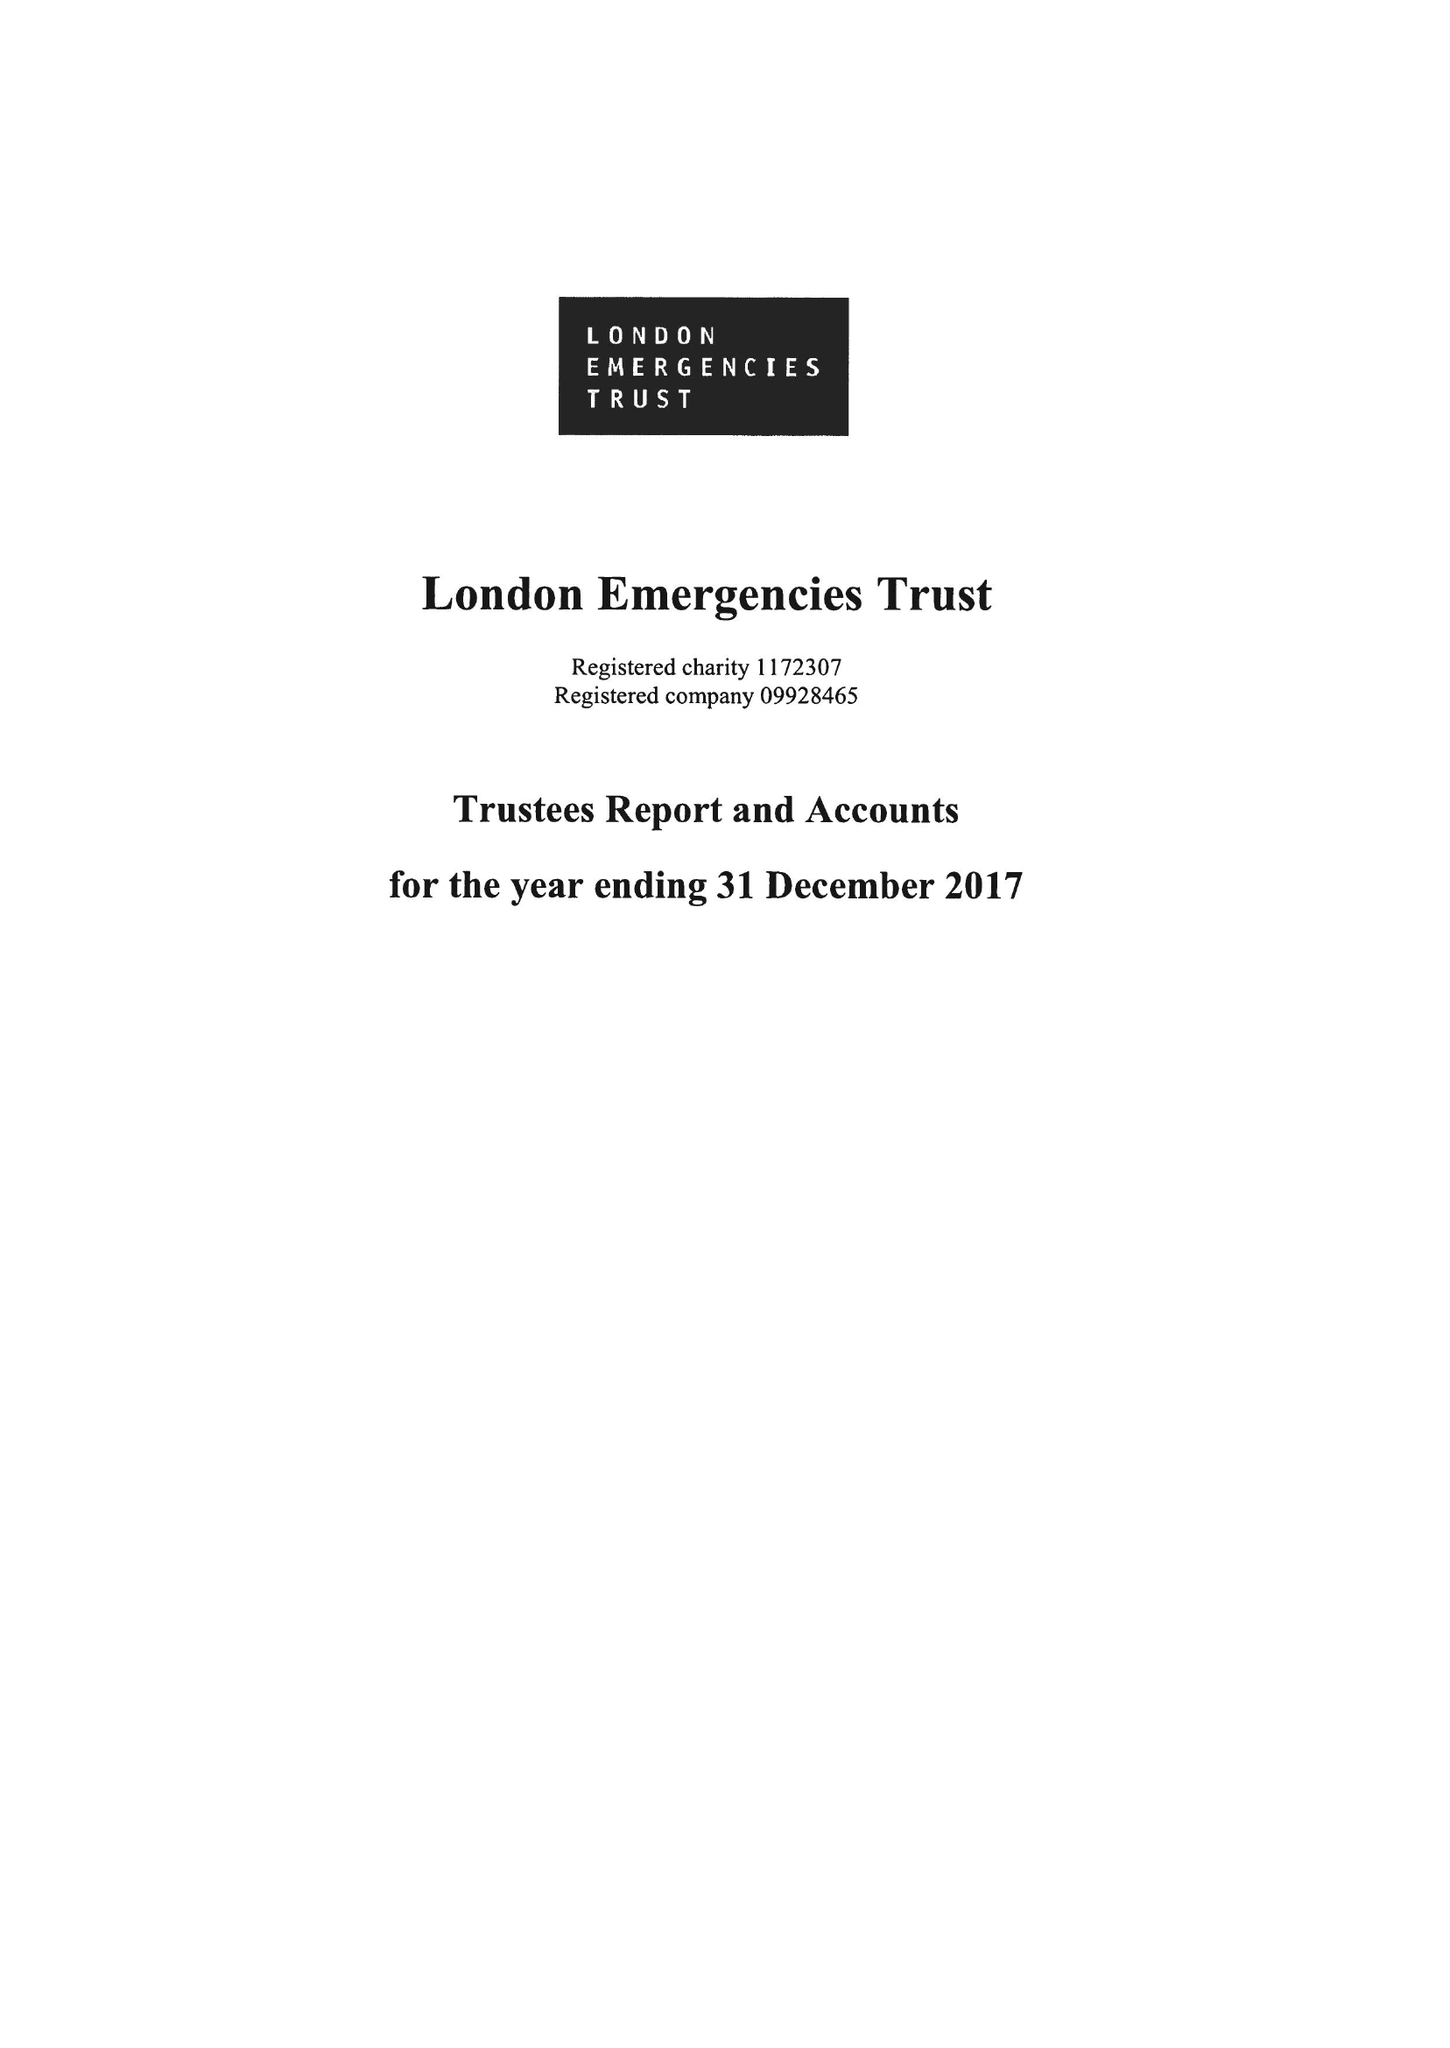What is the value for the charity_name?
Answer the question using a single word or phrase. London Emergencies Trust 